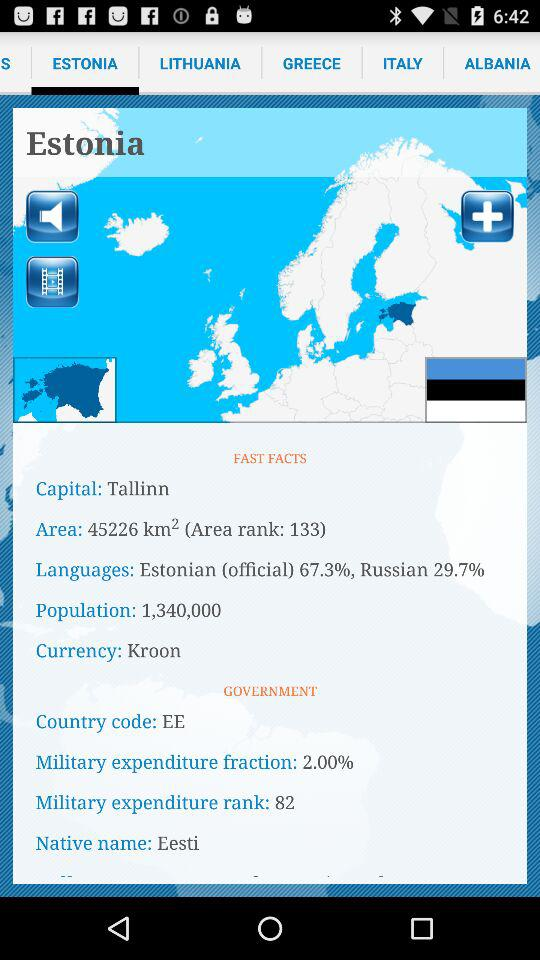What's the capital? The capital is Tallinn. 